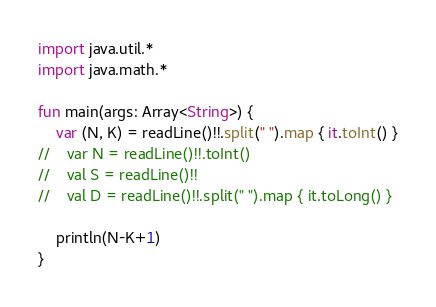<code> <loc_0><loc_0><loc_500><loc_500><_Kotlin_>import java.util.*
import java.math.*

fun main(args: Array<String>) {
    var (N, K) = readLine()!!.split(" ").map { it.toInt() }
//    var N = readLine()!!.toInt()
//    val S = readLine()!!
//    val D = readLine()!!.split(" ").map { it.toLong() }

    println(N-K+1)
}
</code> 